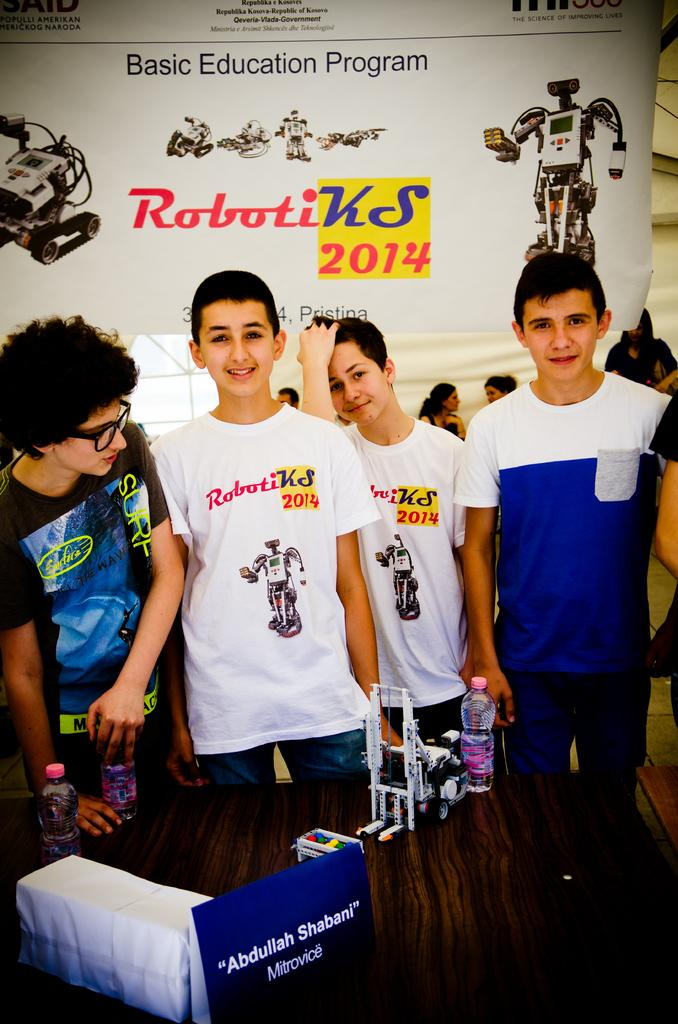<image>
Offer a succinct explanation of the picture presented. Four boys at a RobotiKS 2014 Basic Education Program event. 